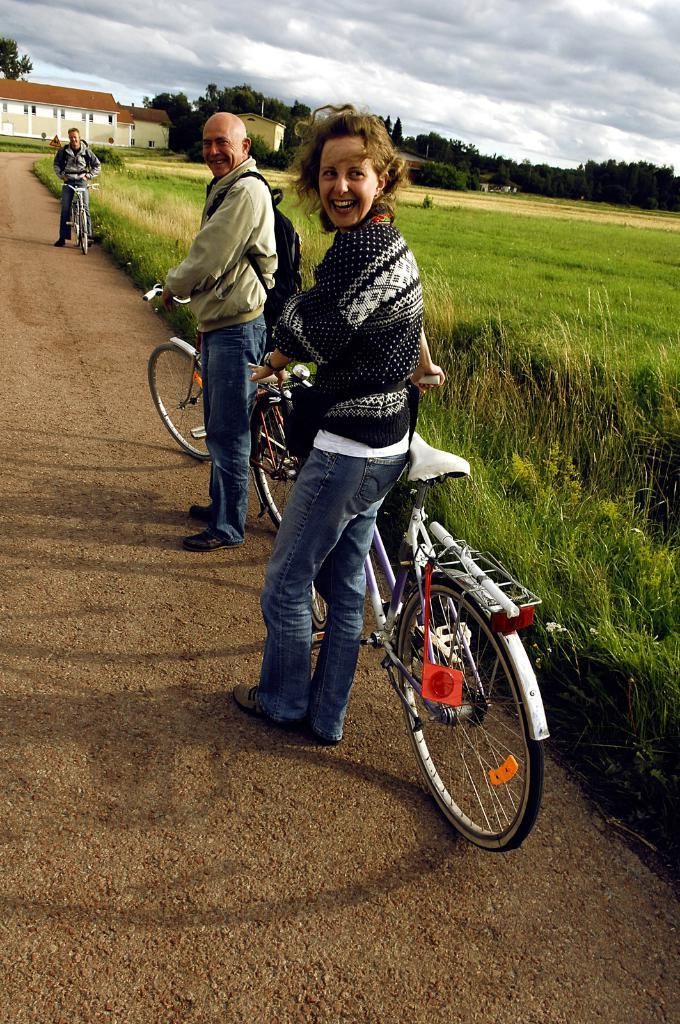How many people are in the image? There are two people in the image, a woman and a man. What are the woman and man doing in the image? The woman and man are standing and holding a bicycle. What can be seen in the background of the image? There are buildings, trees, and the sky visible in the background of the image. What type of surface is visible in the image? There is grass visible in the image. Can you describe any additional activity happening in the background? Yes, there is a person riding a bicycle in the background of the image. What type of news can be heard coming from the truck in the image? There is no truck present in the image, so it is not possible to determine what news might be heard. What is the length of the tail on the bicycle in the image? There is no tail on the bicycle in the image; bicycles do not have tails. 